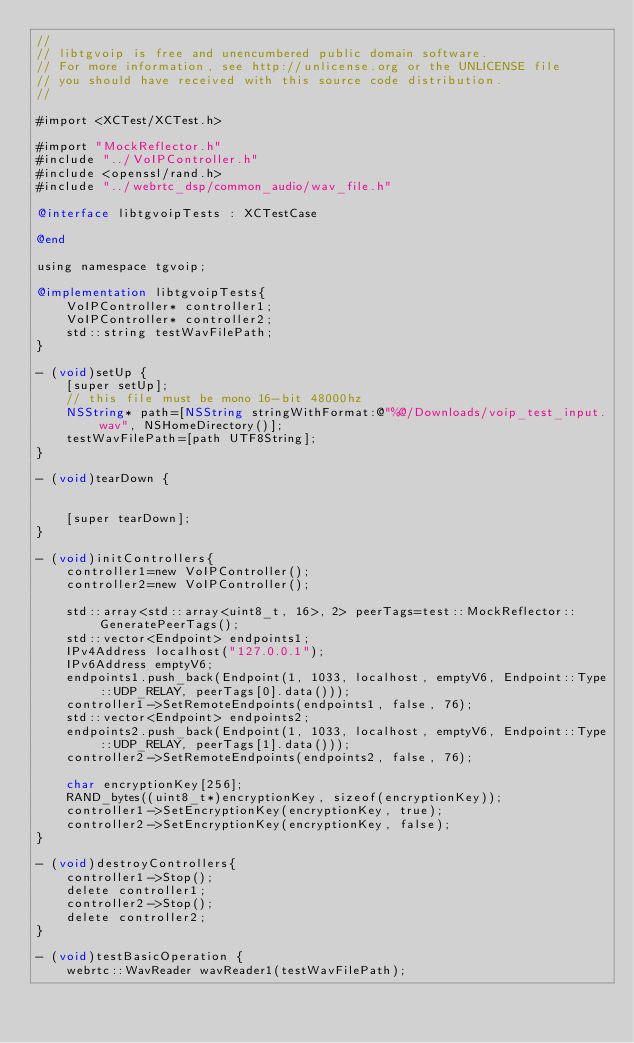<code> <loc_0><loc_0><loc_500><loc_500><_ObjectiveC_>//
// libtgvoip is free and unencumbered public domain software.
// For more information, see http://unlicense.org or the UNLICENSE file
// you should have received with this source code distribution.
//

#import <XCTest/XCTest.h>

#import "MockReflector.h"
#include "../VoIPController.h"
#include <openssl/rand.h>
#include "../webrtc_dsp/common_audio/wav_file.h"

@interface libtgvoipTests : XCTestCase

@end

using namespace tgvoip;

@implementation libtgvoipTests{
	VoIPController* controller1;
	VoIPController* controller2;
	std::string testWavFilePath;
}

- (void)setUp {
    [super setUp];
	// this file must be mono 16-bit 48000hz
	NSString* path=[NSString stringWithFormat:@"%@/Downloads/voip_test_input.wav", NSHomeDirectory()];
	testWavFilePath=[path UTF8String];
}

- (void)tearDown {


    [super tearDown];
}

- (void)initControllers{
	controller1=new VoIPController();
	controller2=new VoIPController();

	std::array<std::array<uint8_t, 16>, 2> peerTags=test::MockReflector::GeneratePeerTags();
	std::vector<Endpoint> endpoints1;
	IPv4Address localhost("127.0.0.1");
	IPv6Address emptyV6;
	endpoints1.push_back(Endpoint(1, 1033, localhost, emptyV6, Endpoint::Type::UDP_RELAY, peerTags[0].data()));
	controller1->SetRemoteEndpoints(endpoints1, false, 76);
	std::vector<Endpoint> endpoints2;
	endpoints2.push_back(Endpoint(1, 1033, localhost, emptyV6, Endpoint::Type::UDP_RELAY, peerTags[1].data()));
	controller2->SetRemoteEndpoints(endpoints2, false, 76);

	char encryptionKey[256];
	RAND_bytes((uint8_t*)encryptionKey, sizeof(encryptionKey));
	controller1->SetEncryptionKey(encryptionKey, true);
	controller2->SetEncryptionKey(encryptionKey, false);
}

- (void)destroyControllers{
	controller1->Stop();
	delete controller1;
	controller2->Stop();
	delete controller2;
}

- (void)testBasicOperation {
	webrtc::WavReader wavReader1(testWavFilePath);</code> 